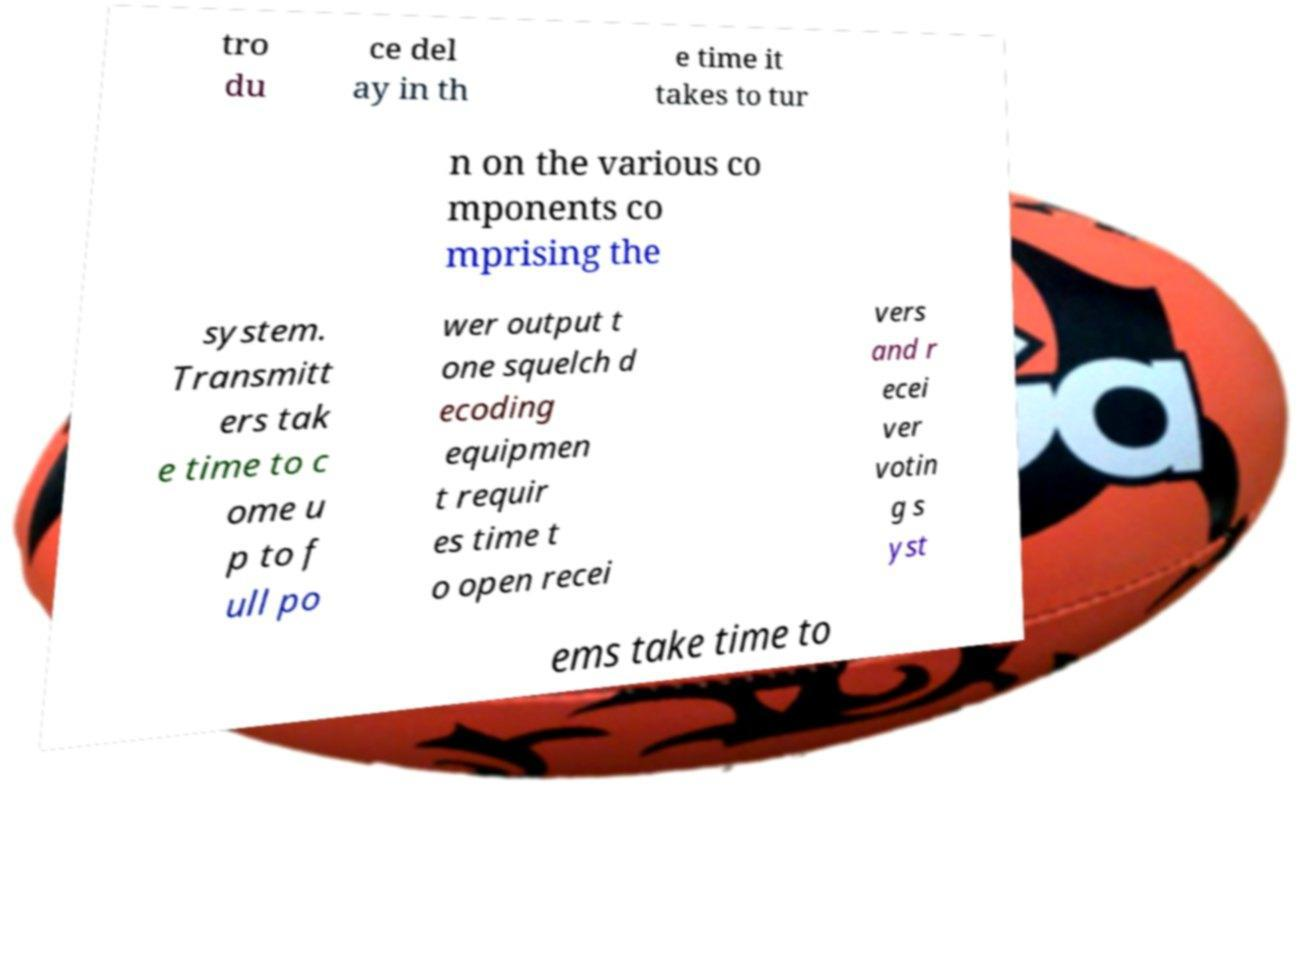Could you assist in decoding the text presented in this image and type it out clearly? tro du ce del ay in th e time it takes to tur n on the various co mponents co mprising the system. Transmitt ers tak e time to c ome u p to f ull po wer output t one squelch d ecoding equipmen t requir es time t o open recei vers and r ecei ver votin g s yst ems take time to 